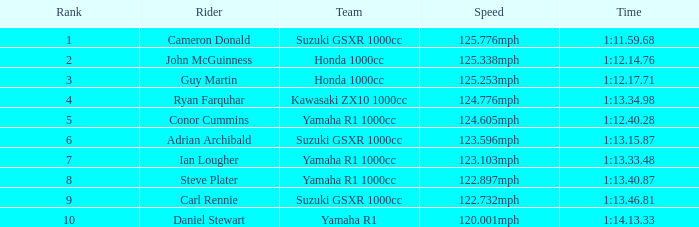What time did team kawasaki zx10 1000cc have? 1:13.34.98. 